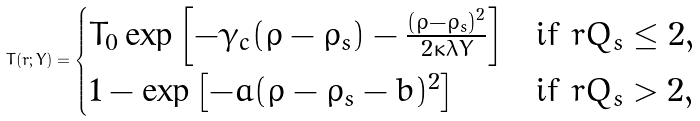Convert formula to latex. <formula><loc_0><loc_0><loc_500><loc_500>T ( r ; Y ) = \begin{cases} T _ { 0 } \exp \left [ - \gamma _ { c } ( \rho - \rho _ { s } ) - \frac { ( \rho - \rho _ { s } ) ^ { 2 } } { 2 \kappa \lambda Y } \right ] & \text {if } r Q _ { s } \leq 2 , \\ 1 - \exp \left [ - a ( \rho - \rho _ { s } - b ) ^ { 2 } \right ] & \text {if } r Q _ { s } > 2 , \end{cases}</formula> 